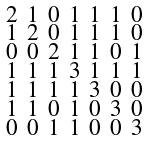Convert formula to latex. <formula><loc_0><loc_0><loc_500><loc_500>\begin{smallmatrix} 2 & 1 & 0 & 1 & 1 & 1 & 0 \\ 1 & 2 & 0 & 1 & 1 & 1 & 0 \\ 0 & 0 & 2 & 1 & 1 & 0 & 1 \\ 1 & 1 & 1 & 3 & 1 & 1 & 1 \\ 1 & 1 & 1 & 1 & 3 & 0 & 0 \\ 1 & 1 & 0 & 1 & 0 & 3 & 0 \\ 0 & 0 & 1 & 1 & 0 & 0 & 3 \end{smallmatrix}</formula> 